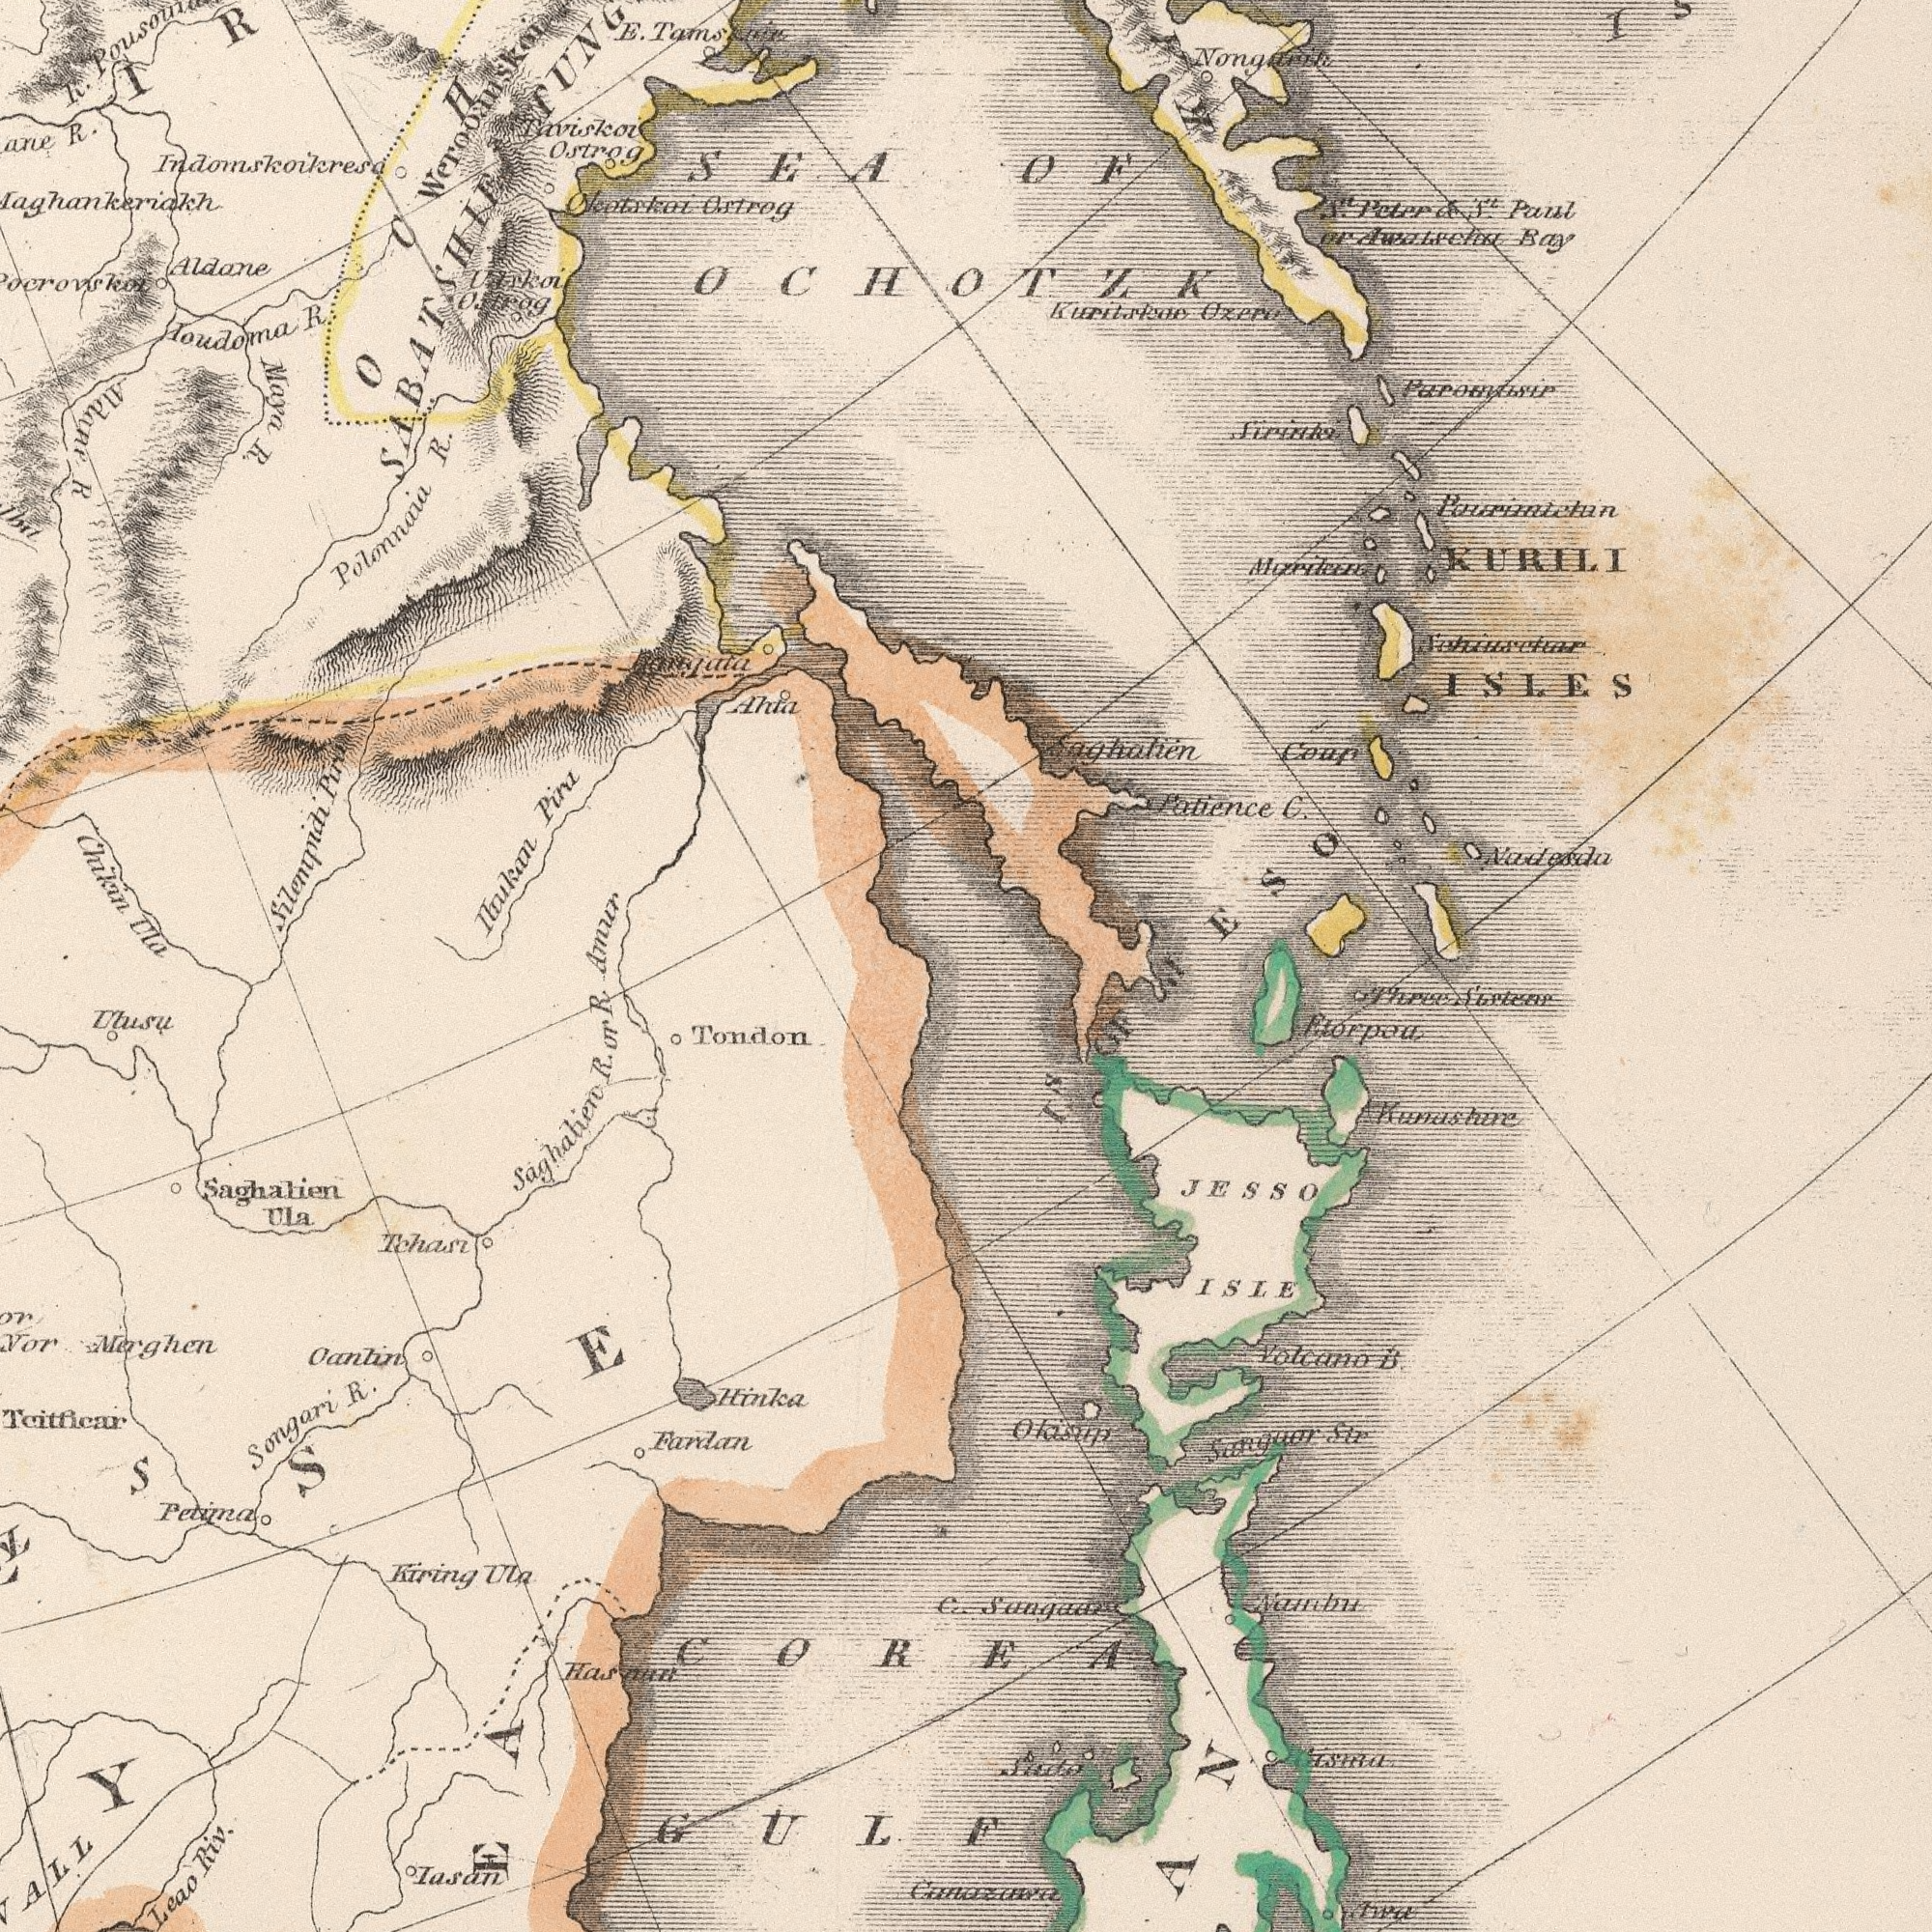What text is visible in the lower-right corner? GULF COREA C. JESSO Awa ISLE Sanguar B Nainbu Str Volcano Three Kunashire I<sup>s</sup> OF Sisters What text can you see in the top-right section? KURILI Patience Nadesda Kuritskae Bay C. Paul Coup Peter Ozerv ISLES S<sup>t</sup>. S<sup>t</sup>. Saghatien OF OCHOTZK JESO What text can you see in the top-left section? Polonnaia Ostrog Chikan Maya Ioudoma Silenipidi R. Aldane Ula R Ostrog R. Taviskoi ###ala Amur Okotskai Ahta R. Pina Aldanp R. R. SABATSHIE Indomskoikresa Weroomsk SEA E. Ostrog What text is shown in the bottom-left quadrant? Saghatien ###SE Hinka Leao Tondon Songari Teitficar Tchasi Iasan Ualsu Fardan ###Y Oantin R. Ula Saghalien Riv. Ula Petima R. Merghen Kiring R or 